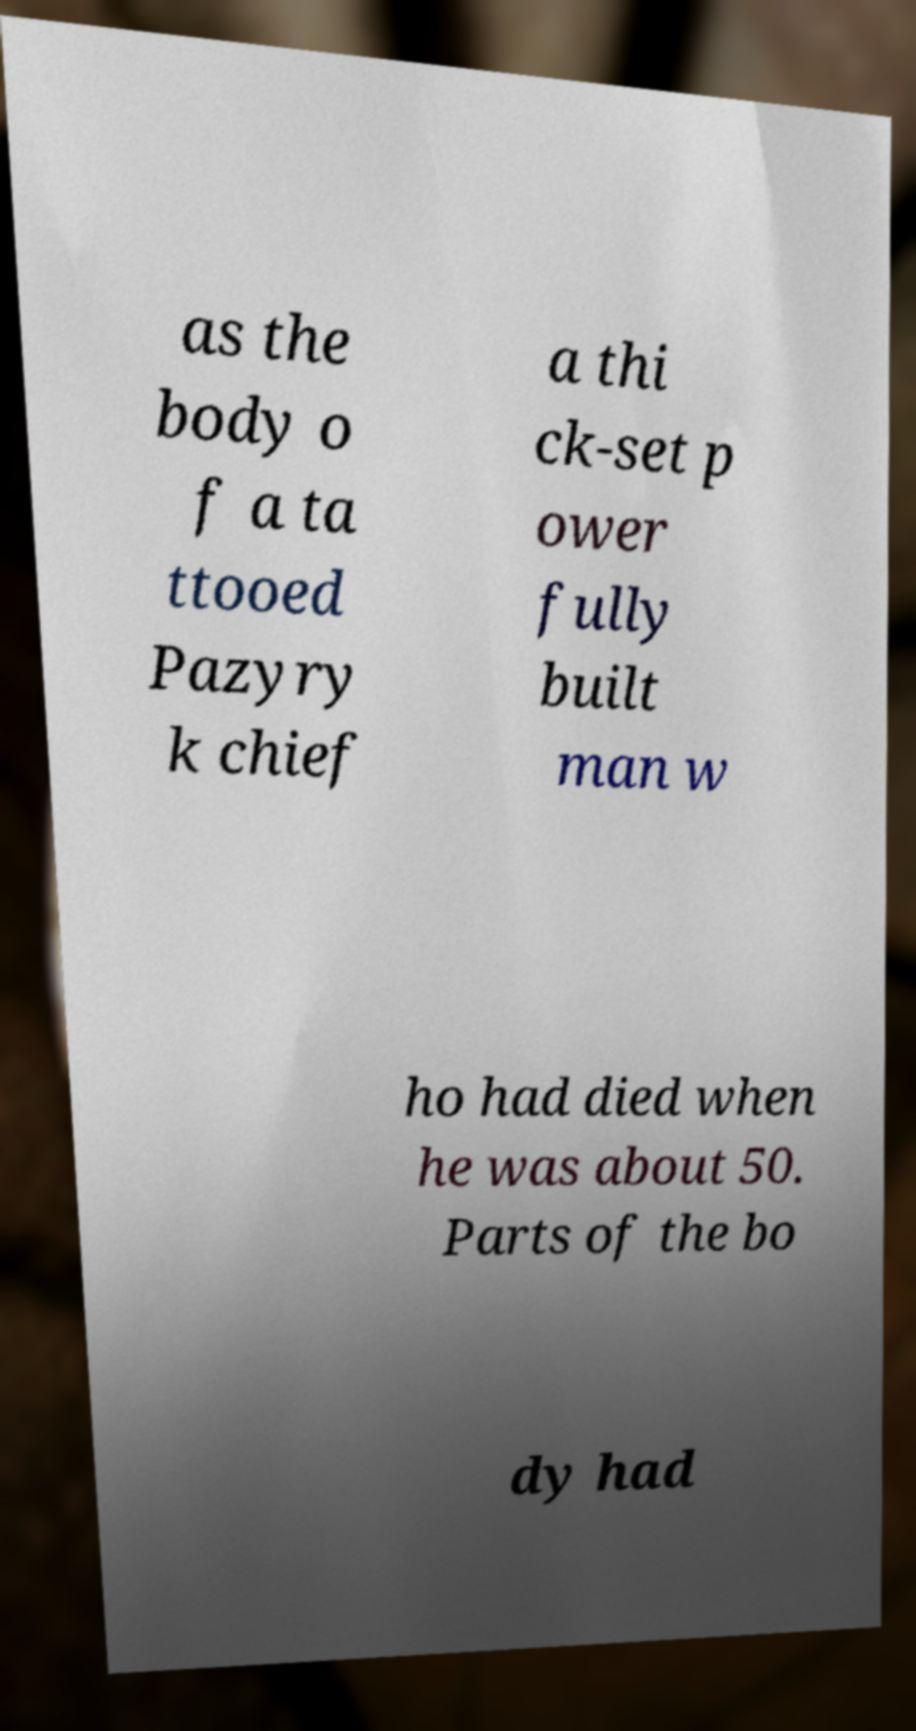Could you assist in decoding the text presented in this image and type it out clearly? as the body o f a ta ttooed Pazyry k chief a thi ck-set p ower fully built man w ho had died when he was about 50. Parts of the bo dy had 